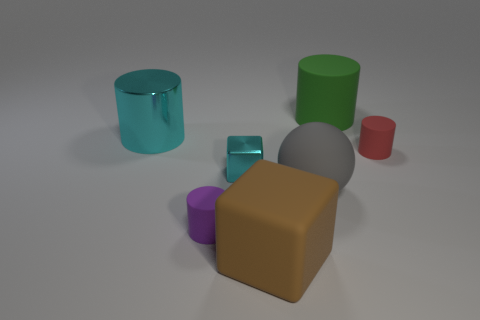What is the size of the purple thing?
Make the answer very short. Small. What number of things are either red matte things or big objects in front of the big cyan shiny thing?
Provide a succinct answer. 3. What number of other objects are there of the same color as the large matte block?
Offer a terse response. 0. Does the gray rubber thing have the same size as the cylinder that is behind the big cyan metallic object?
Offer a terse response. Yes. Do the rubber cylinder that is left of the matte sphere and the big rubber block have the same size?
Offer a terse response. No. What number of other objects are there of the same material as the large block?
Give a very brief answer. 4. Are there the same number of brown objects right of the brown object and big rubber cylinders in front of the purple cylinder?
Provide a succinct answer. Yes. The matte cylinder that is on the right side of the green matte cylinder that is left of the tiny cylinder that is on the right side of the brown rubber cube is what color?
Keep it short and to the point. Red. There is a large cyan metallic object behind the red thing; what is its shape?
Offer a very short reply. Cylinder. What shape is the large brown thing that is made of the same material as the green cylinder?
Offer a very short reply. Cube. 